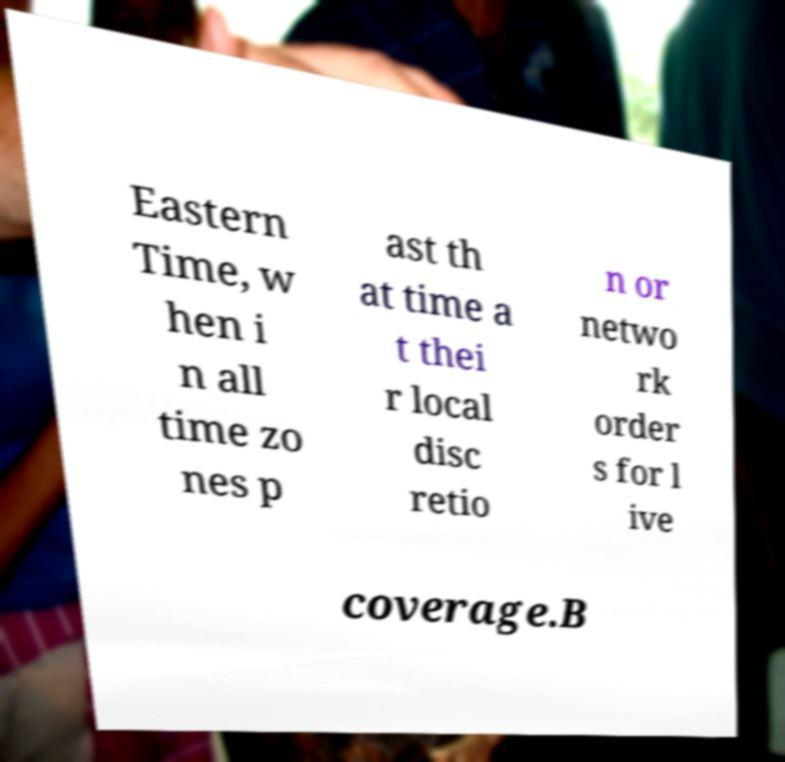There's text embedded in this image that I need extracted. Can you transcribe it verbatim? Eastern Time, w hen i n all time zo nes p ast th at time a t thei r local disc retio n or netwo rk order s for l ive coverage.B 